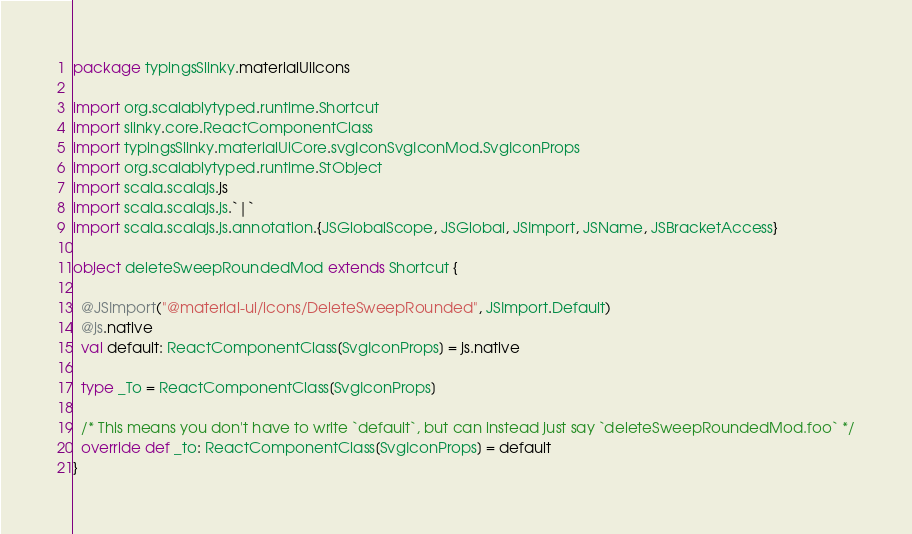<code> <loc_0><loc_0><loc_500><loc_500><_Scala_>package typingsSlinky.materialUiIcons

import org.scalablytyped.runtime.Shortcut
import slinky.core.ReactComponentClass
import typingsSlinky.materialUiCore.svgIconSvgIconMod.SvgIconProps
import org.scalablytyped.runtime.StObject
import scala.scalajs.js
import scala.scalajs.js.`|`
import scala.scalajs.js.annotation.{JSGlobalScope, JSGlobal, JSImport, JSName, JSBracketAccess}

object deleteSweepRoundedMod extends Shortcut {
  
  @JSImport("@material-ui/icons/DeleteSweepRounded", JSImport.Default)
  @js.native
  val default: ReactComponentClass[SvgIconProps] = js.native
  
  type _To = ReactComponentClass[SvgIconProps]
  
  /* This means you don't have to write `default`, but can instead just say `deleteSweepRoundedMod.foo` */
  override def _to: ReactComponentClass[SvgIconProps] = default
}
</code> 